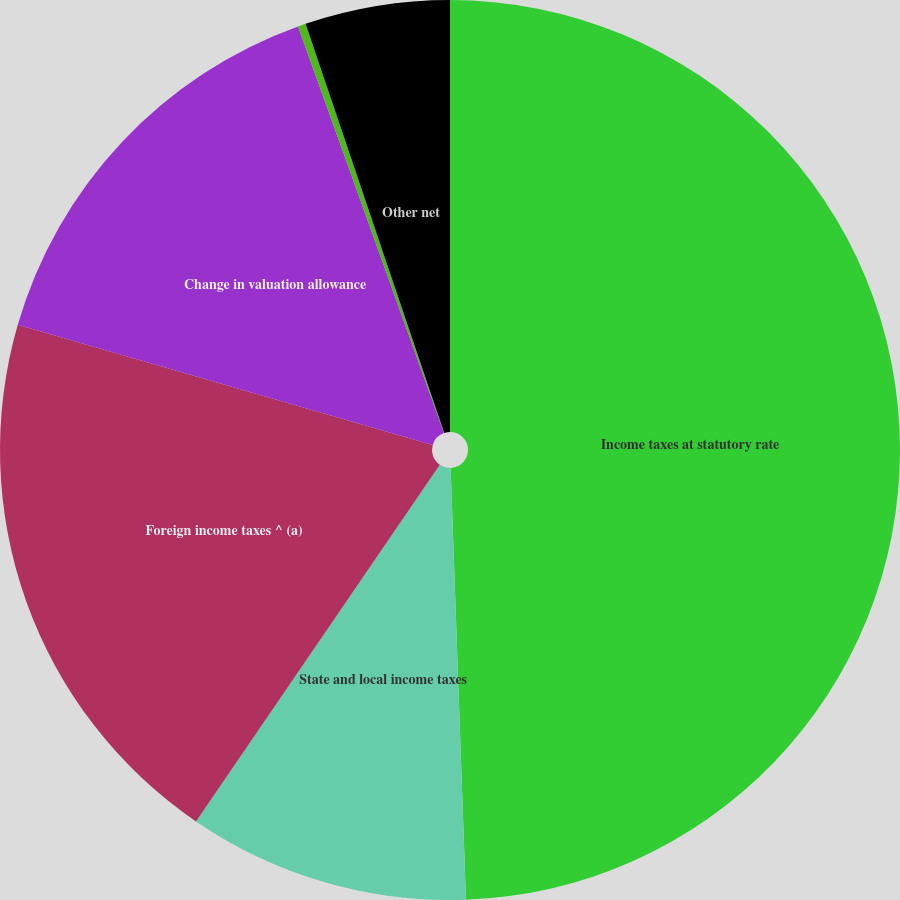<chart> <loc_0><loc_0><loc_500><loc_500><pie_chart><fcel>Income taxes at statutory rate<fcel>State and local income taxes<fcel>Foreign income taxes ^ (a)<fcel>Change in valuation allowance<fcel>Tax contingencies and audit<fcel>Other net<nl><fcel>49.43%<fcel>10.11%<fcel>19.94%<fcel>15.03%<fcel>0.28%<fcel>5.2%<nl></chart> 